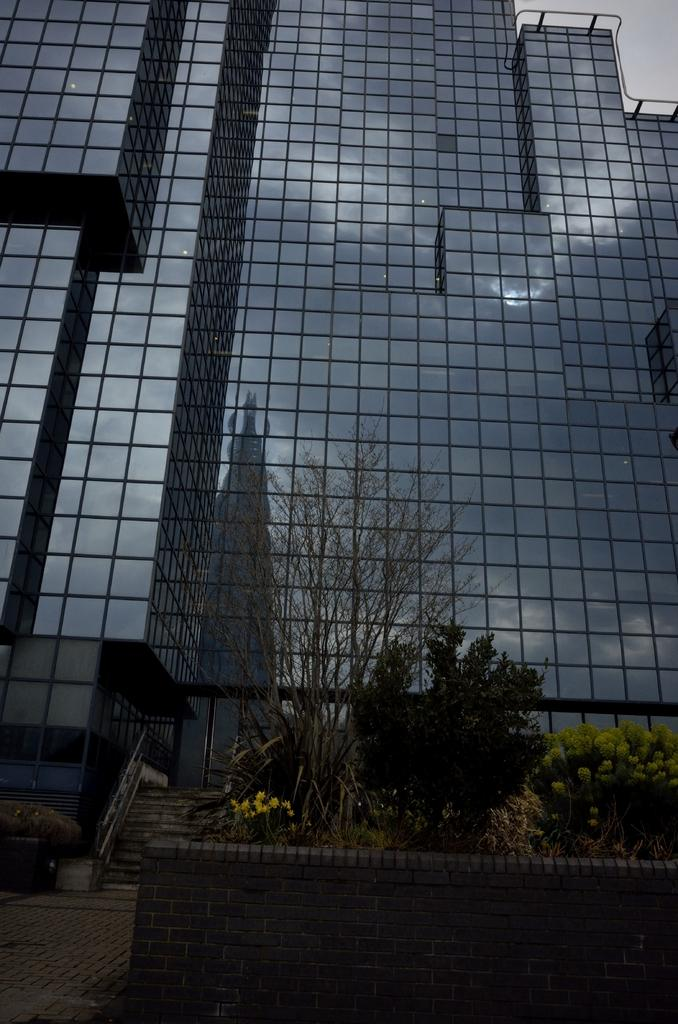What is present in the image that separates two areas or spaces? There is a wall in the image. What is on top of the wall? Plants are on top of the wall. What can be seen in the distance in the image? There is a building in the background of the image. Are there any architectural features visible in the background? Yes, there is a staircase in the background of the image. What is the price of the tomatoes growing on the wall in the image? There are no tomatoes present in the image, so it is not possible to determine their price. 